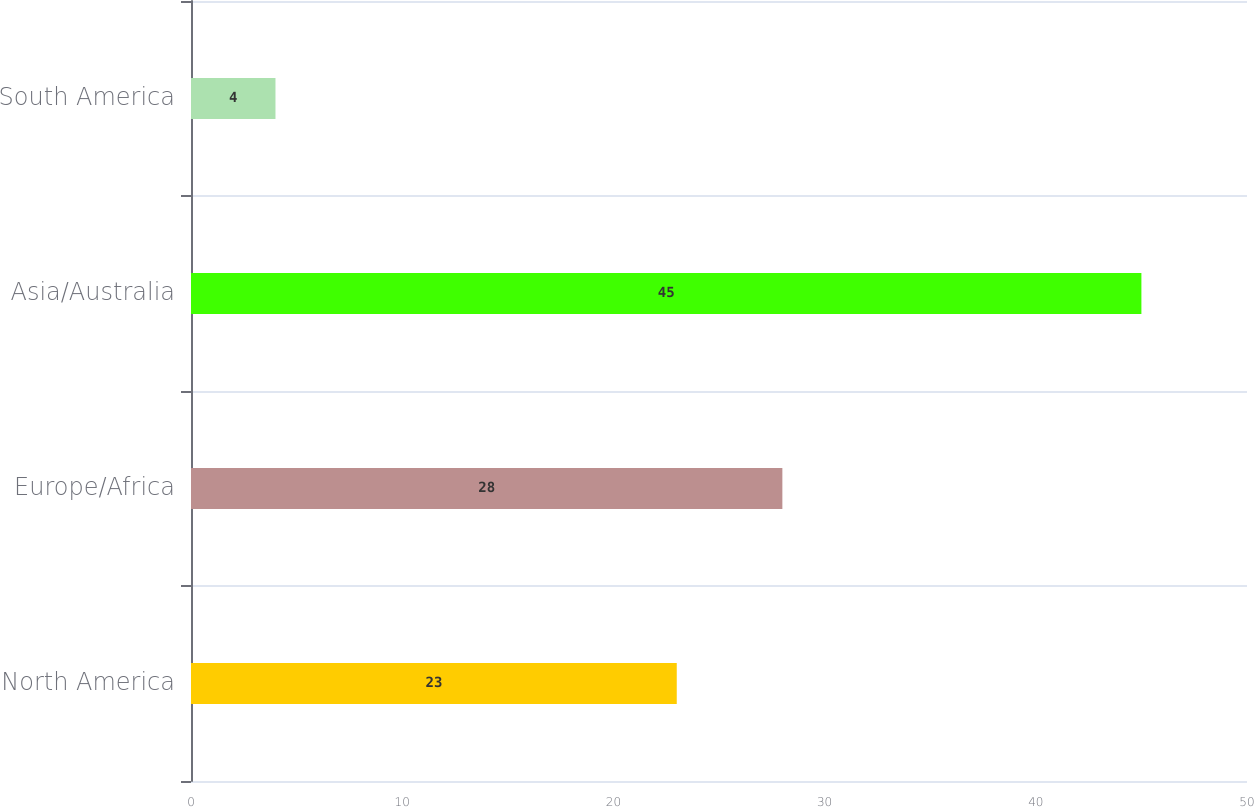Convert chart. <chart><loc_0><loc_0><loc_500><loc_500><bar_chart><fcel>North America<fcel>Europe/Africa<fcel>Asia/Australia<fcel>South America<nl><fcel>23<fcel>28<fcel>45<fcel>4<nl></chart> 